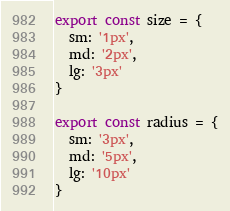Convert code to text. <code><loc_0><loc_0><loc_500><loc_500><_JavaScript_>export const size = {
  sm: '1px',
  md: '2px',
  lg: '3px'
}

export const radius = {
  sm: '3px',
  md: '5px',
  lg: '10px'
}
</code> 